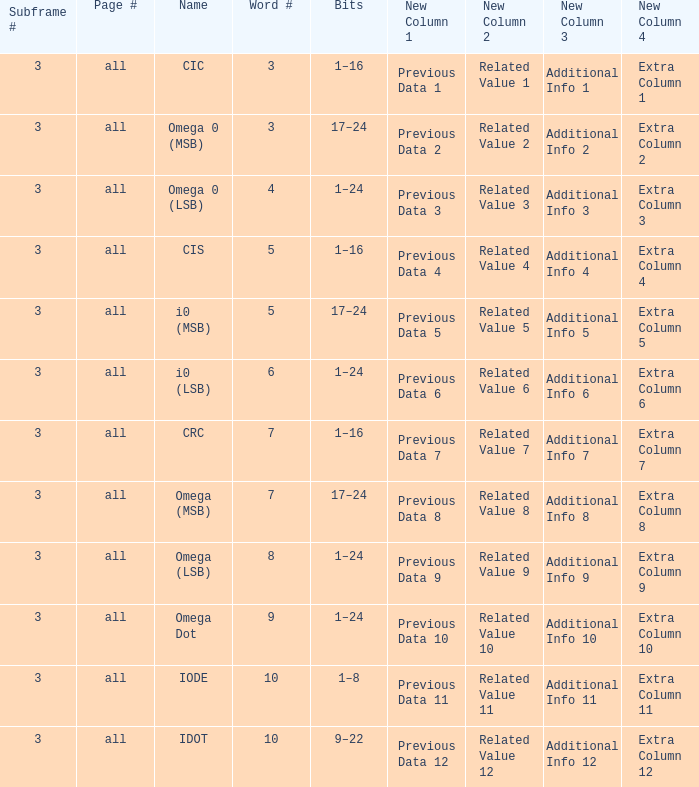What is the word count that is named omega dot? 9.0. 